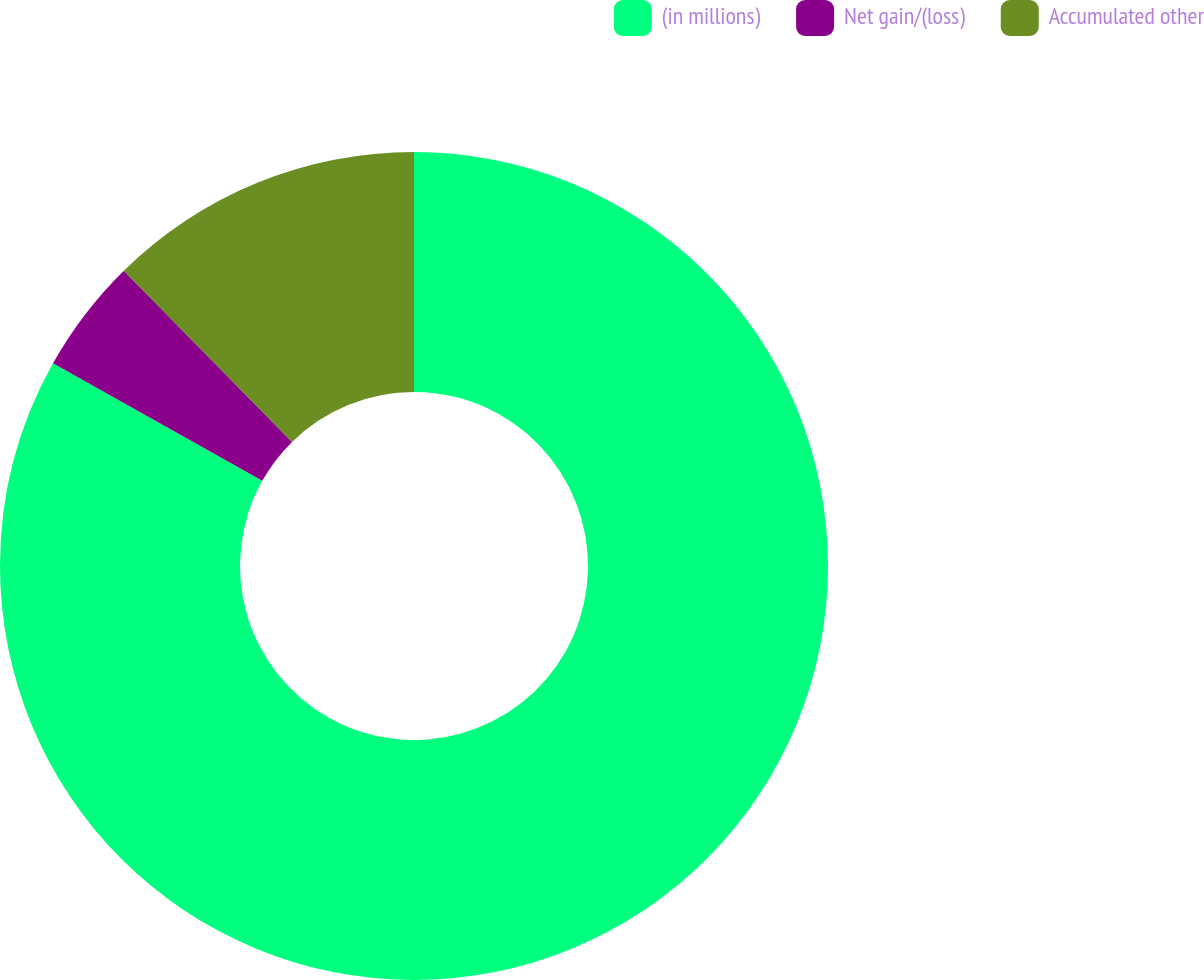Convert chart. <chart><loc_0><loc_0><loc_500><loc_500><pie_chart><fcel>(in millions)<fcel>Net gain/(loss)<fcel>Accumulated other<nl><fcel>83.14%<fcel>4.5%<fcel>12.36%<nl></chart> 